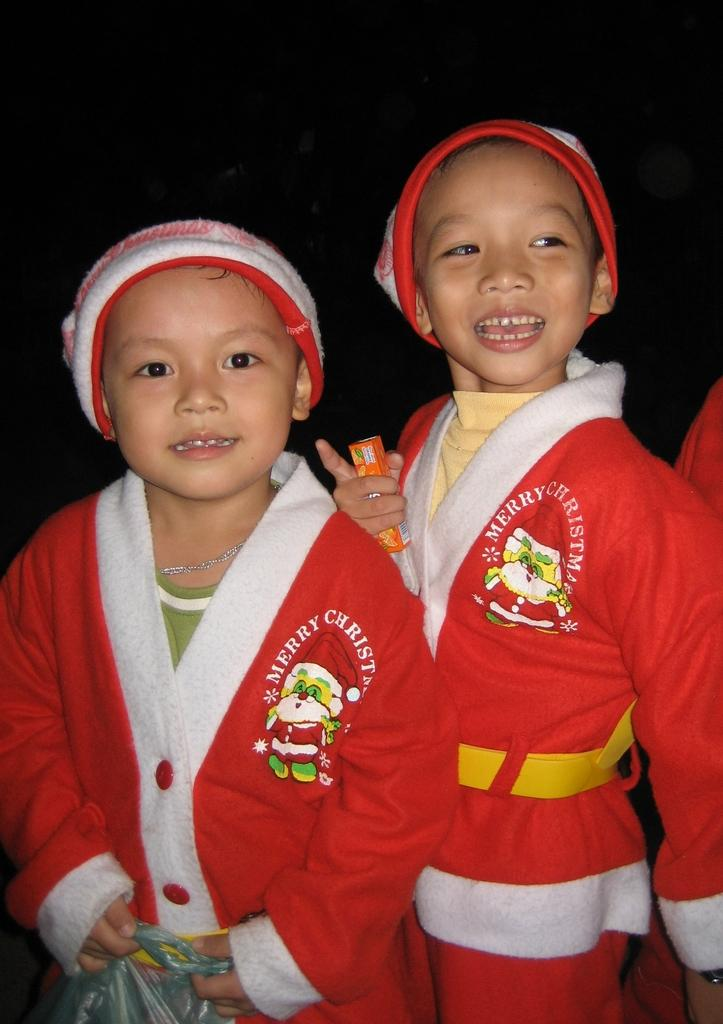<image>
Summarize the visual content of the image. Two boys wearing red and white Santa robes that say Merry Christmas/ 